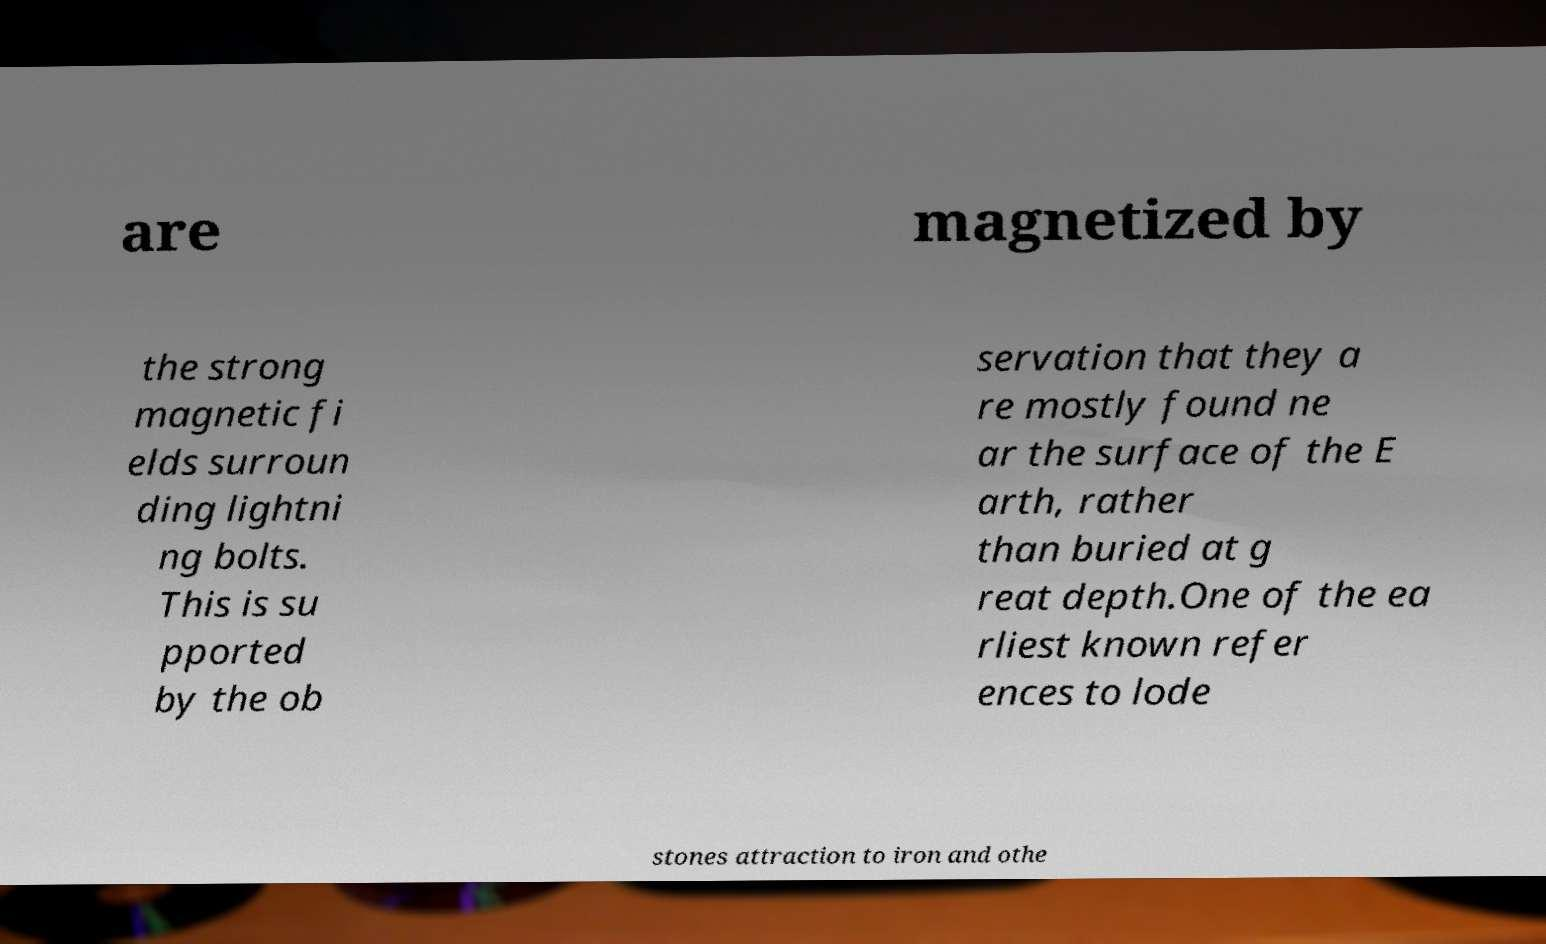What messages or text are displayed in this image? I need them in a readable, typed format. are magnetized by the strong magnetic fi elds surroun ding lightni ng bolts. This is su pported by the ob servation that they a re mostly found ne ar the surface of the E arth, rather than buried at g reat depth.One of the ea rliest known refer ences to lode stones attraction to iron and othe 